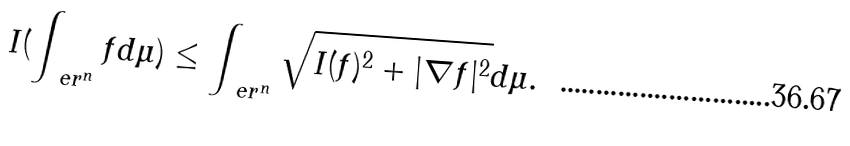<formula> <loc_0><loc_0><loc_500><loc_500>I ( \int _ { \ e r ^ { n } } f d \mu ) \leq \int _ { \ e r ^ { n } } \sqrt { I ( f ) ^ { 2 } + | \nabla f | ^ { 2 } } d \mu .</formula> 